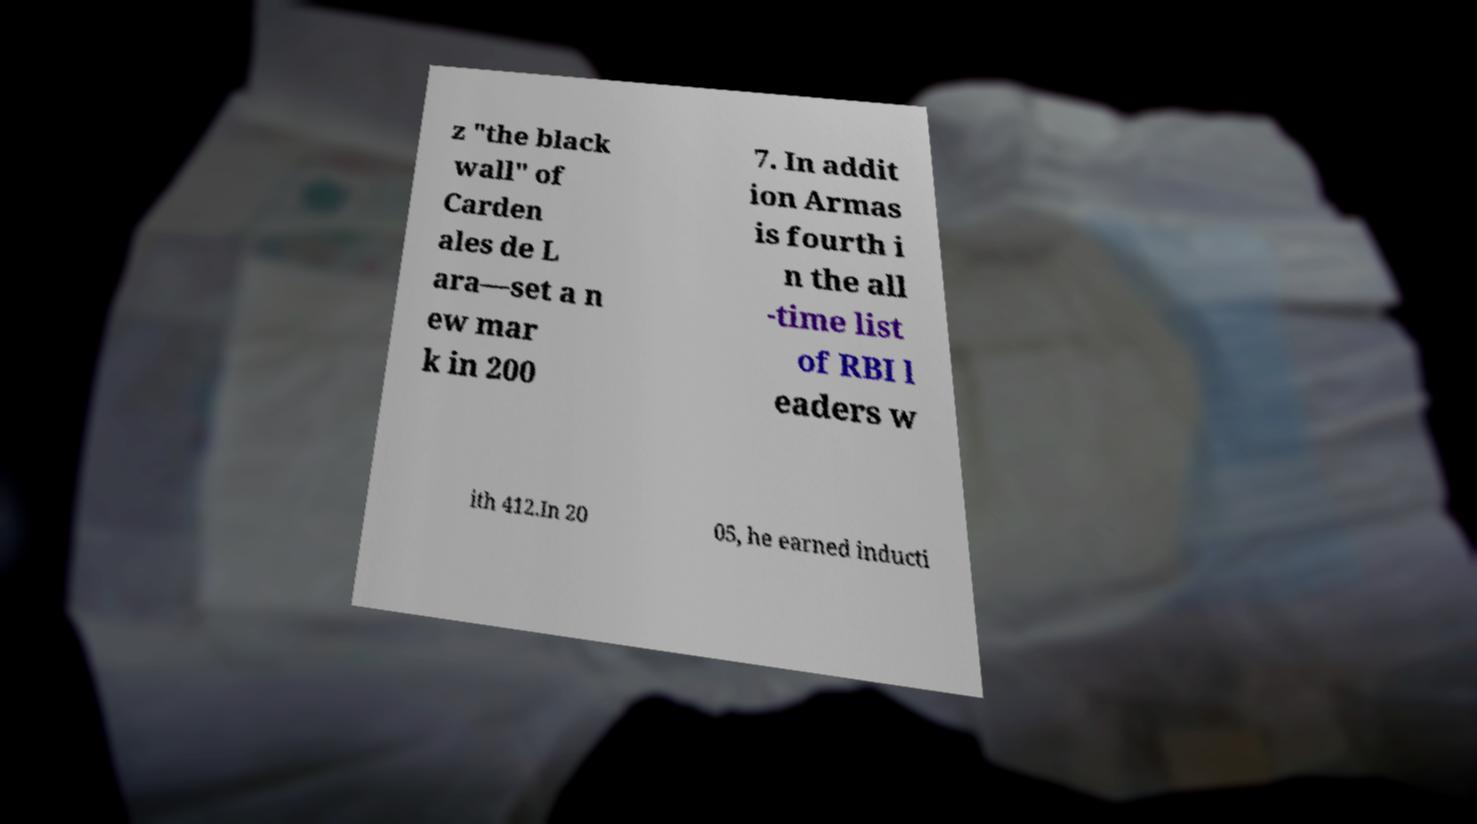Could you extract and type out the text from this image? z "the black wall" of Carden ales de L ara—set a n ew mar k in 200 7. In addit ion Armas is fourth i n the all -time list of RBI l eaders w ith 412.In 20 05, he earned inducti 